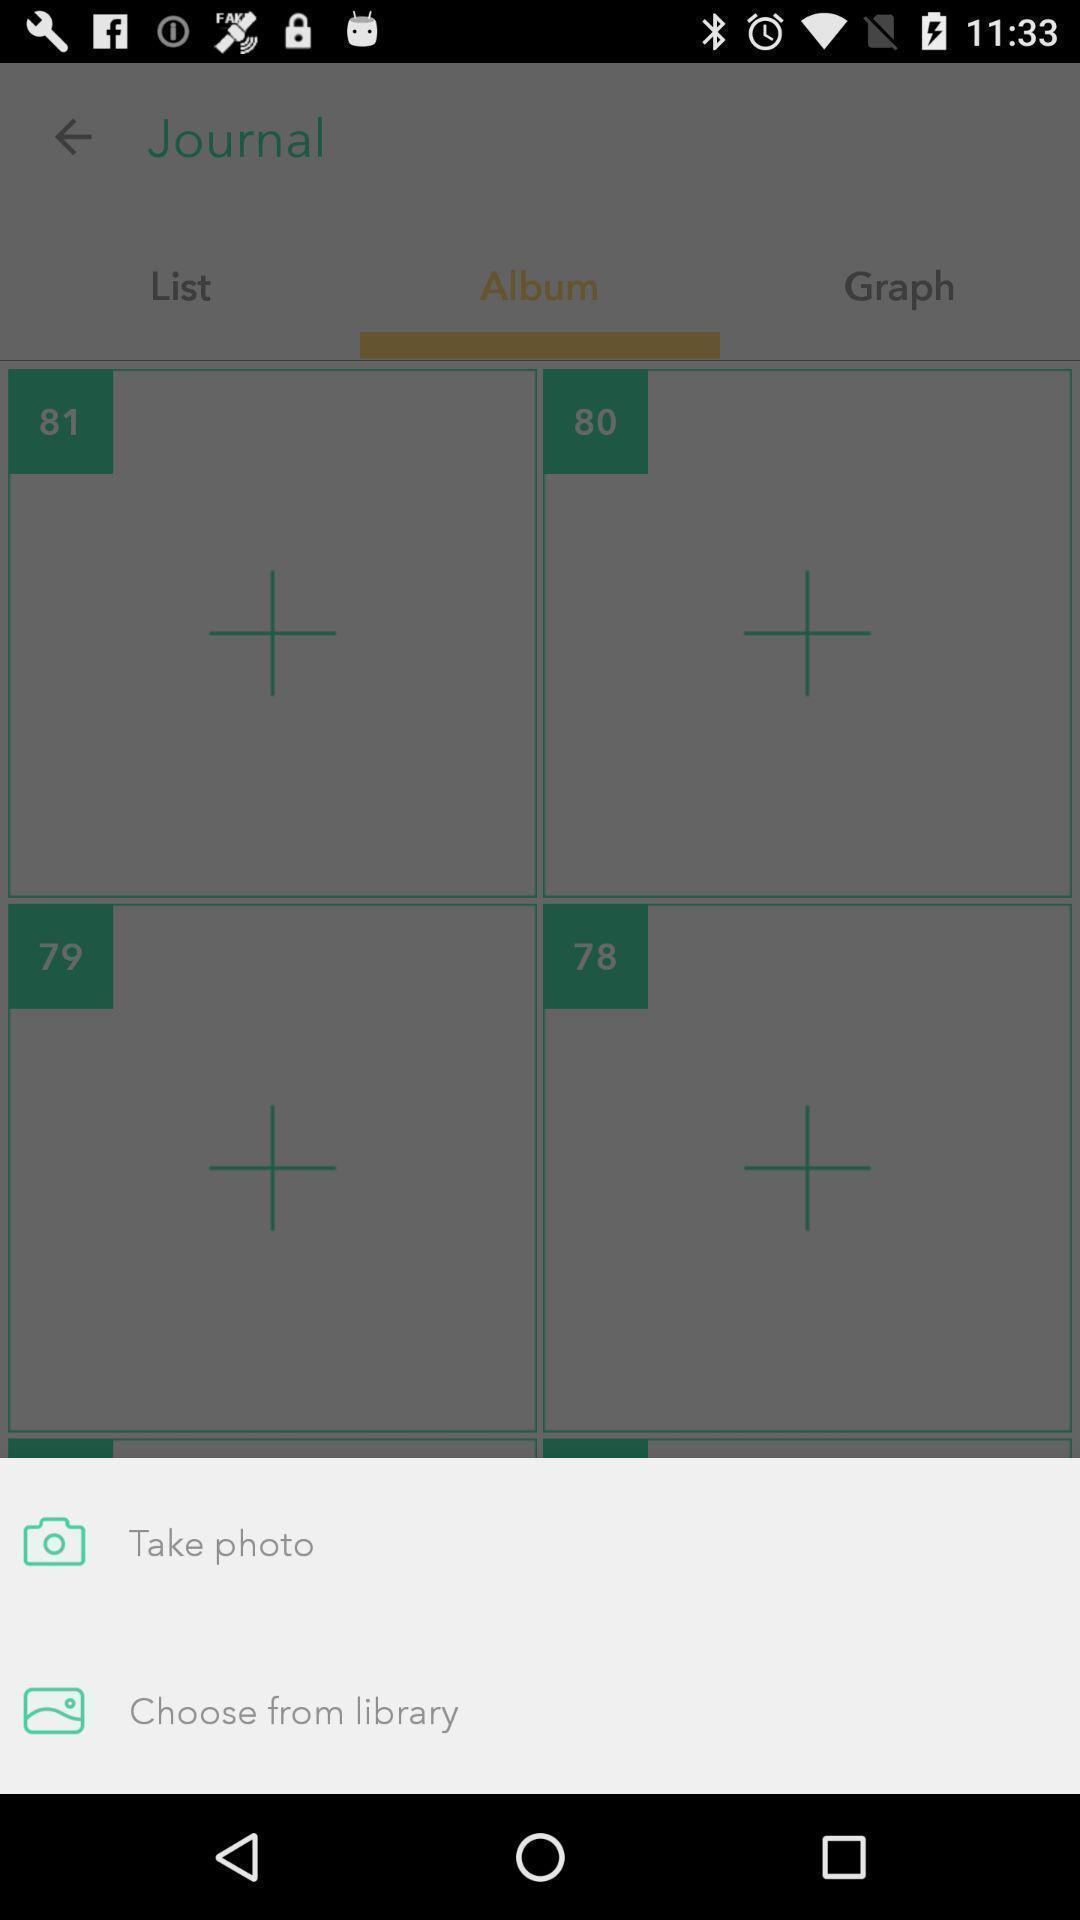Explain the elements present in this screenshot. Popup of options to upload the image through them. 